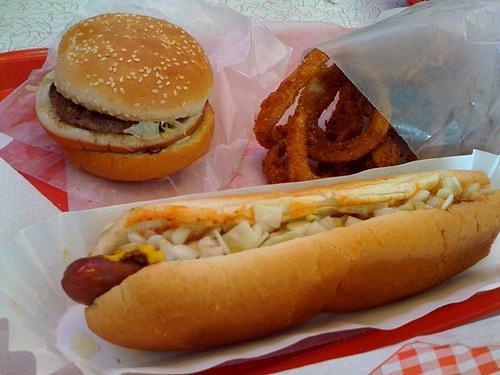How many bottoms does the hamburger bun have?
Give a very brief answer. 2. How many hot dogs are visible?
Give a very brief answer. 1. How many sandwiches are there?
Give a very brief answer. 2. 